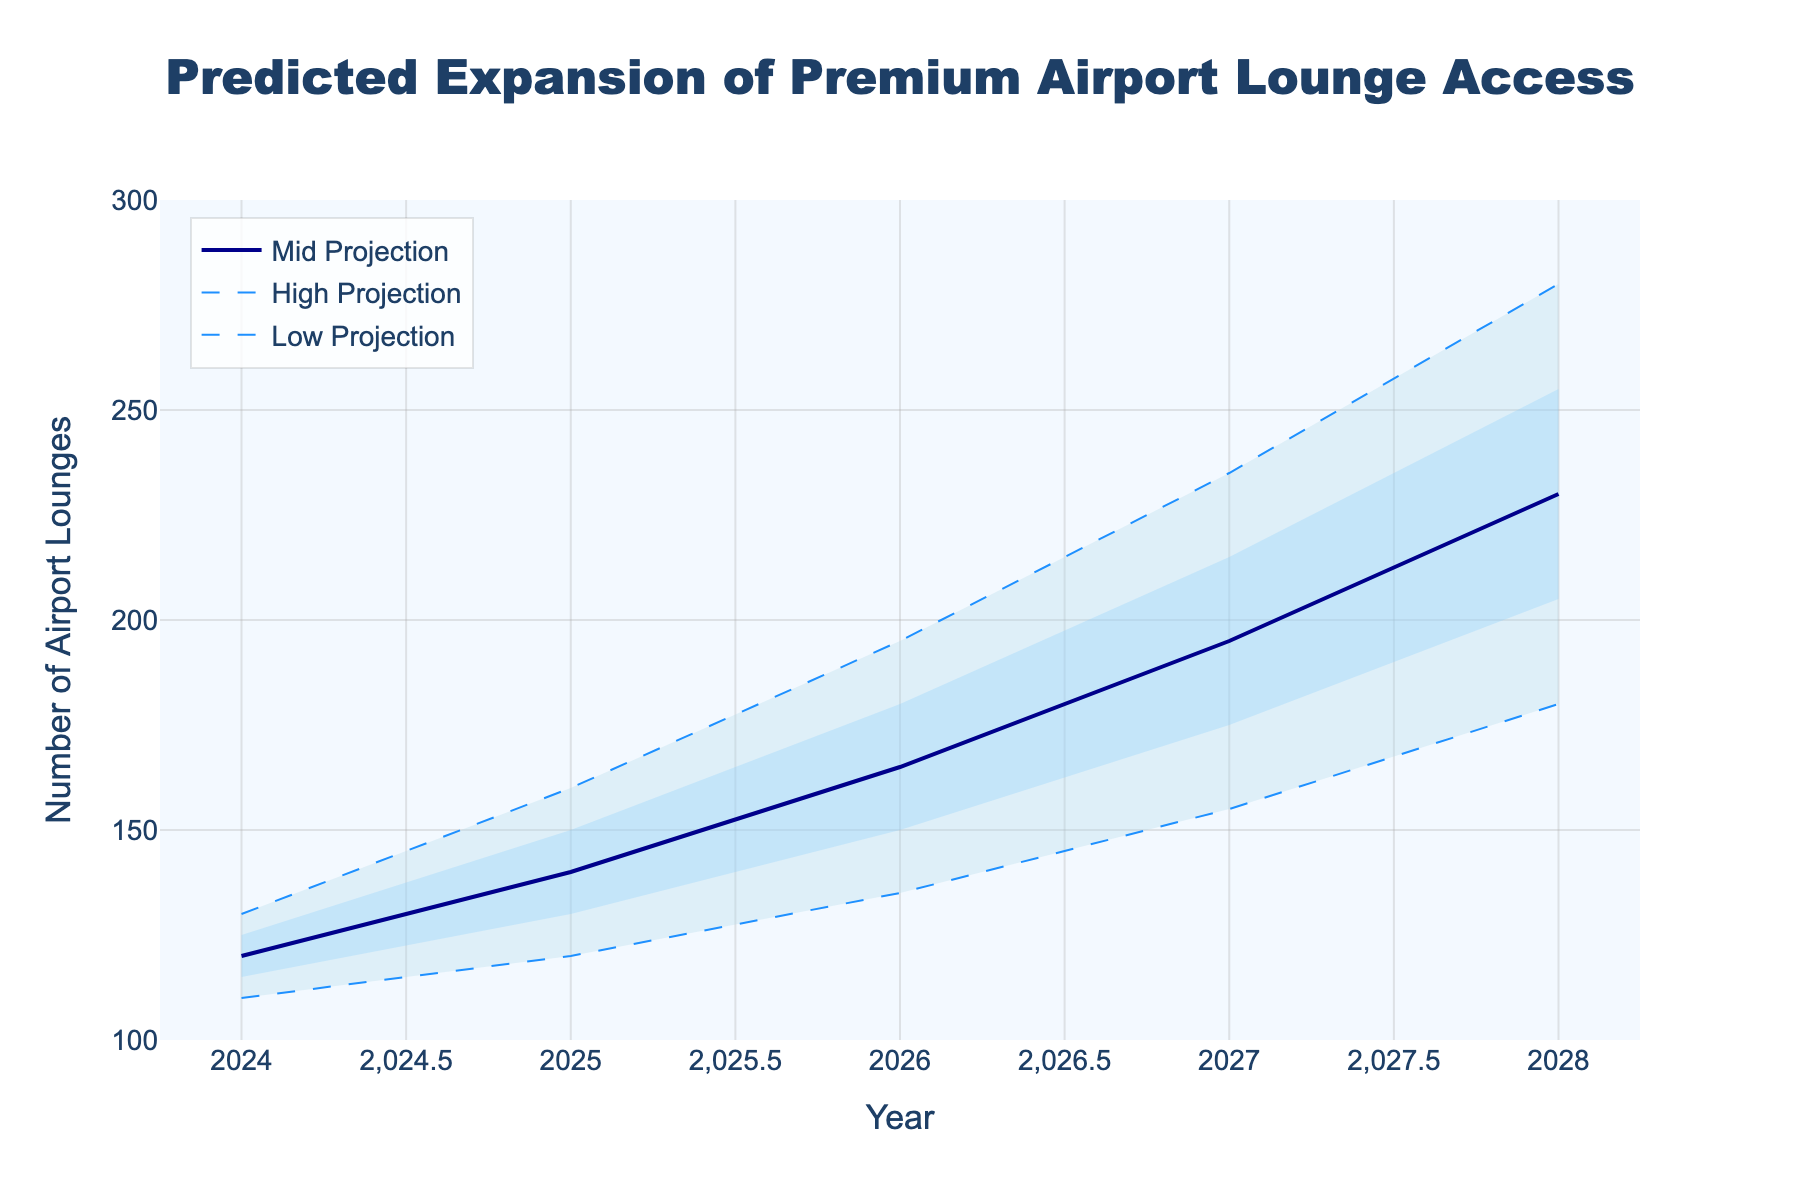How many data points are plotted for each year? Each year has a 'Low', 'Low-Mid', 'Mid', 'Mid-High', and 'High' data point, so there are 5 data points for each year.
Answer: 5 What is the title of the figure? The title of the figure is displayed at the top of the plot.
Answer: Predicted Expansion of Premium Airport Lounge Access In what year does the 'Mid' projection reach 165 lounges? By looking at the 'Mid' projection line, it reaches 165 lounges in the year 2026.
Answer: 2026 How does the number of lounges change between 2024 and 2028 for the 'High' projection? In 2024, the 'High' projection is 130 lounges, and in 2028 it is 280 lounges. The difference is 280 - 130 = 150 lounges.
Answer: Increases by 150 lounges Which projection shows the steepest increase over the period? The 'High' projection shows the steepest increase, from 130 lounges in 2024 to 280 lounges in 2028.
Answer: High projection What is the difference between the 'Mid-High' and 'Low-Mid' projections in 2027? The 'Mid-High' projection in 2027 is 215 lounges, and the 'Low-Mid' projection is 175 lounges. The difference is 215 - 175 = 40 lounges.
Answer: 40 lounges Is the 'Mid' projection always within the range created by the 'Low' and 'High' projections? Yes, the 'Mid' projection is always plotted between the 'Low' and 'High' projections, indicating it lies within the range created by them.
Answer: Yes When does the 'Mid-High' projection exceed 200 lounges? The 'Mid-High' projection exceeds 200 lounges in the year 2028, as seen on the 'Mid-High' projection line.
Answer: 2028 What is the projected number of lounges in the 'Low' projection for 2025? The 'Low' projection for 2025 is shown directly on the chart, which is 120 lounges.
Answer: 120 How many projections indicate more than 160 lounges in 2027? The projections 'Mid', 'Mid-High', and 'High' for 2027 all indicate more than 160 lounges.
Answer: 3 